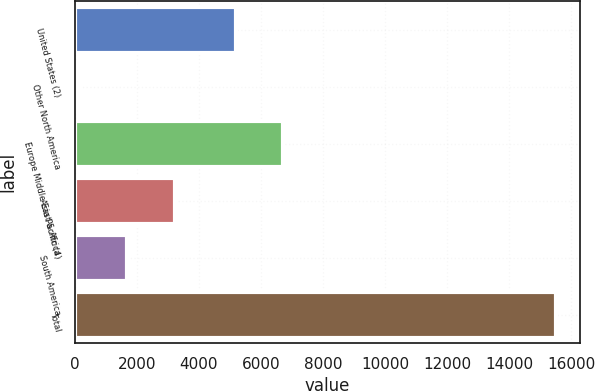<chart> <loc_0><loc_0><loc_500><loc_500><bar_chart><fcel>United States (2)<fcel>Other North America<fcel>Europe Middle East & Africa<fcel>Asia Pacific (4)<fcel>South America<fcel>Total<nl><fcel>5193<fcel>151<fcel>6729.8<fcel>3224.6<fcel>1687.8<fcel>15519<nl></chart> 